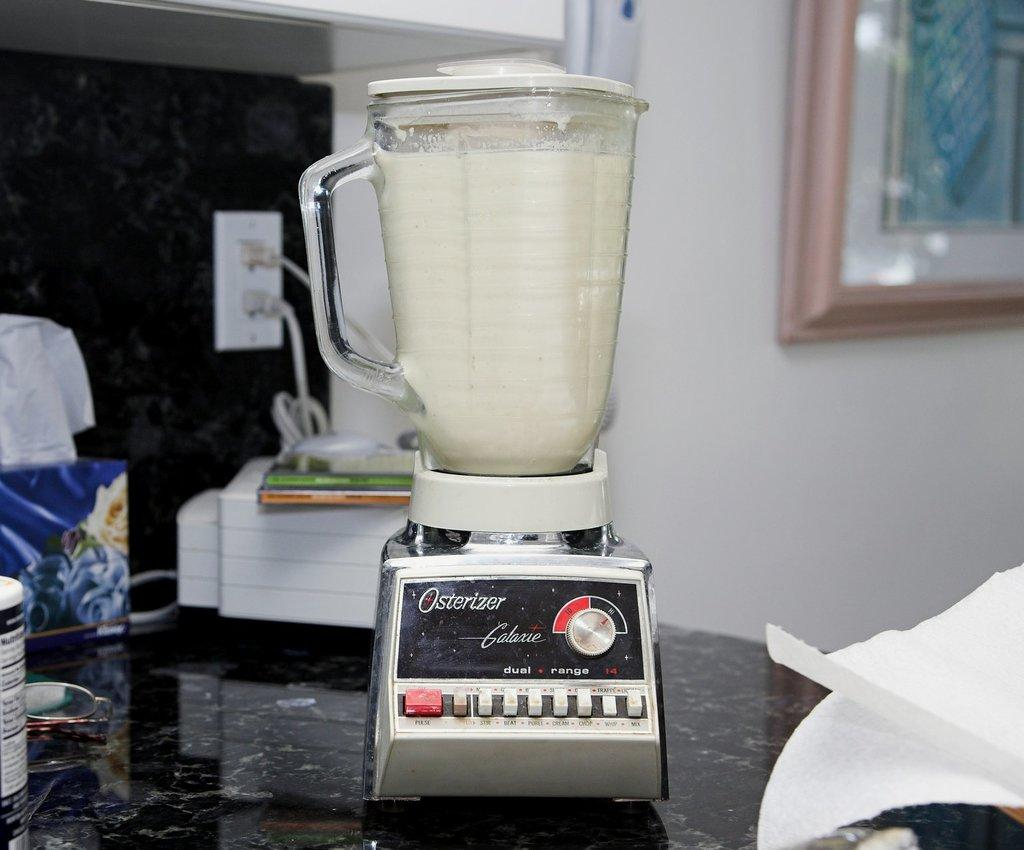<image>
Give a short and clear explanation of the subsequent image. An Osterizer blender sits on the kitchen counter. 